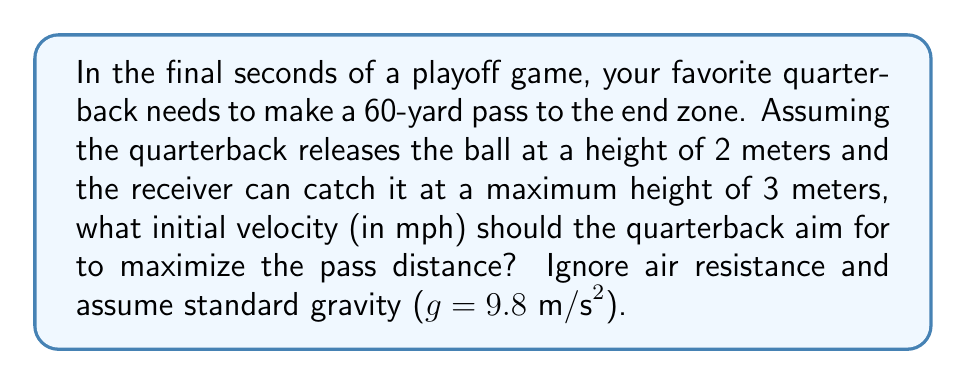Can you solve this math problem? Let's approach this step-by-step using projectile motion equations:

1) The optimal angle for maximum distance in projectile motion is 45°. We'll use this angle for our calculations.

2) We can use the range equation for projectile motion:

   $$R = \frac{v_0^2 \sin(2\theta)}{g}$$

   Where $R$ is the range (60 yards = 54.86 meters), $v_0$ is the initial velocity, $\theta$ is the launch angle (45°), and $g$ is gravity (9.8 m/s²).

3) Substituting our known values:

   $$54.86 = \frac{v_0^2 \sin(90°)}{9.8}$$

4) Simplify:

   $$54.86 = \frac{v_0^2}{9.8}$$

5) Solve for $v_0$:

   $$v_0 = \sqrt{54.86 \times 9.8} = 23.18 \text{ m/s}$$

6) Convert to mph:

   $$23.18 \text{ m/s} \times \frac{3600 \text{ s}}{1 \text{ hr}} \times \frac{1 \text{ mile}}{1609.34 \text{ m}} = 51.85 \text{ mph}$$

7) To verify if this velocity allows the ball to reach the receiver at 3 meters height:

   Use the equation: $$y = y_0 + v_0 \sin(\theta)t - \frac{1}{2}gt^2$$

   Where $y$ is 3 m, $y_0$ is 2 m, $v_0$ is 23.18 m/s, $\theta$ is 45°, and $t$ is the time to reach the receiver (54.86 m / (23.18 m/s * cos(45°)) = 3.34 s)

   $$3 = 2 + 23.18 \sin(45°)(3.34) - \frac{1}{2}(9.8)(3.34)^2$$
   
   $$3 ≈ 2.97$$ (within rounding error)

Therefore, this initial velocity allows the ball to reach the receiver at the required height.
Answer: 51.85 mph 